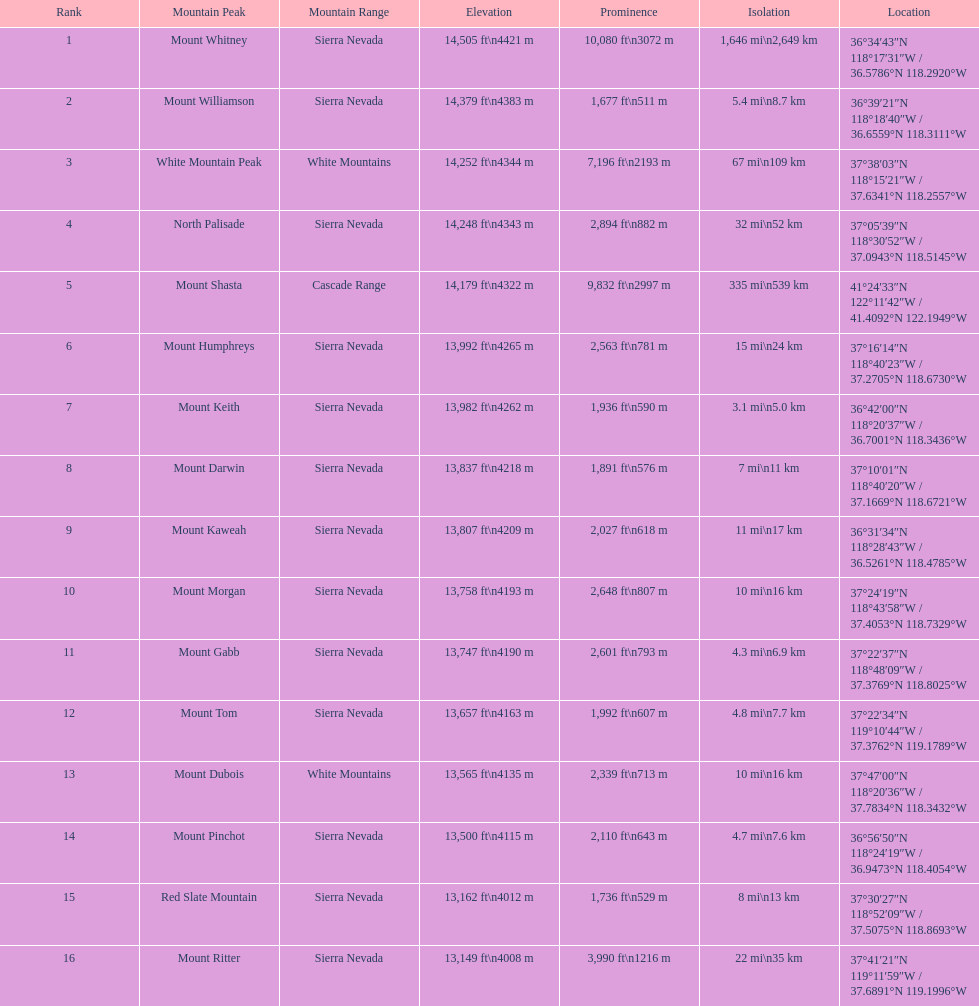What is the elevation difference between mount williamson's peak and mount keith's peak? 397 ft. 